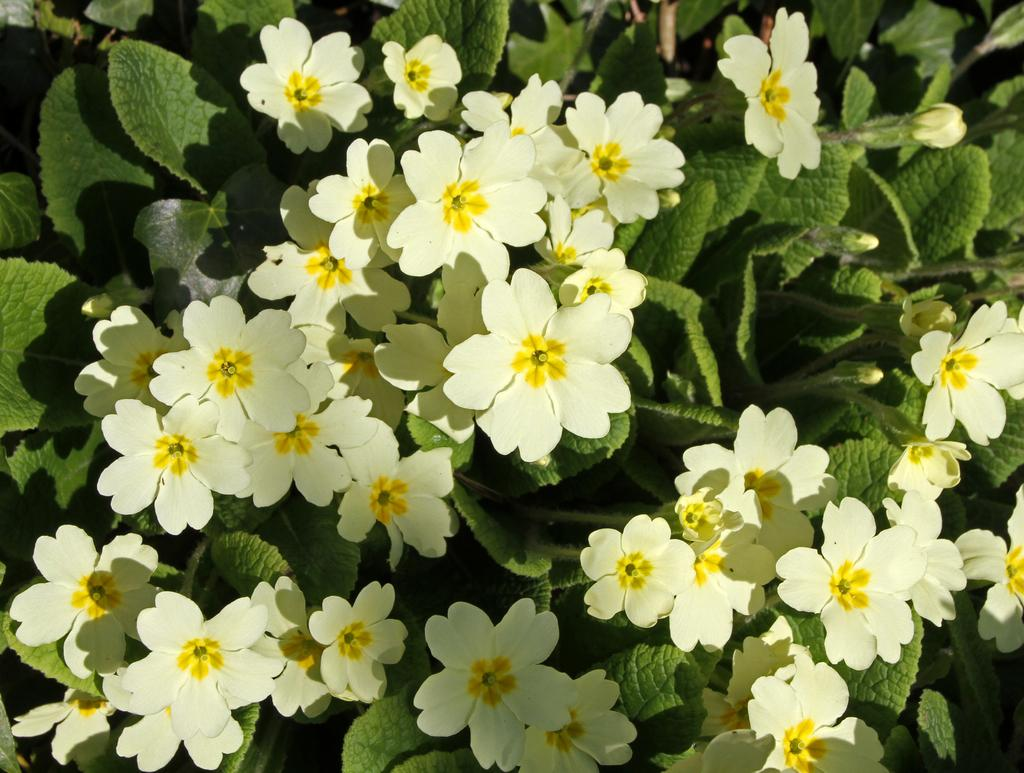What color are the flowers on the plants in the image? The flowers on the plants are white. Can you describe the stage of the flowers on the plants? There are flower buds on the plants. What type of government is depicted in the image? There is no government depicted in the image; it features white color flowers on plants with flower buds. 